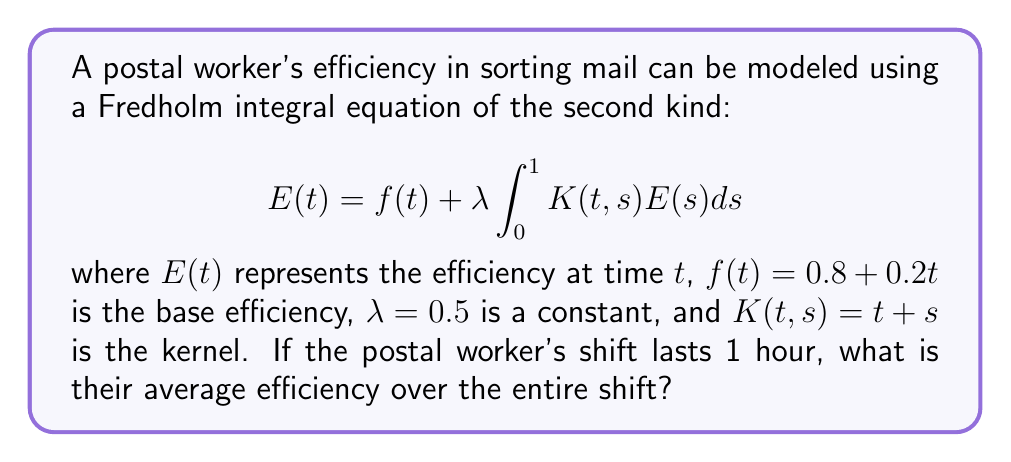Can you answer this question? To solve this problem, we'll follow these steps:

1) First, we need to solve the Fredholm integral equation to find $E(t)$. We'll assume a solution of the form:
   $$E(t) = a + bt$$

2) Substituting this into the original equation:
   $$(a + bt) = (0.8 + 0.2t) + 0.5 \int_0^1 (t+s)(a + bs)ds$$

3) Evaluate the integral:
   $$\int_0^1 (t+s)(a + bs)ds = \int_0^1 (at + as + bst + bs^2)ds$$
   $$= at + as|_0^1 + bst|_0^1 + \frac{1}{3}bs^3|_0^1$$
   $$= at + a + \frac{1}{2}bt + \frac{1}{3}b$$

4) Substituting back:
   $$(a + bt) = (0.8 + 0.2t) + 0.5(at + a + \frac{1}{2}bt + \frac{1}{3}b)$$

5) Equating coefficients of $t$ and constant terms:
   For $t$: $b = 0.2 + 0.5a + 0.25b$
   Constant: $a = 0.8 + 0.5a + \frac{1}{6}b$

6) Solve this system of equations:
   $0.75b = 0.2 + 0.5a$
   $0.5a = 0.8 - \frac{1}{6}b$

   Solving these, we get: $a \approx 1.0909$ and $b \approx 0.7273$

7) Therefore, $E(t) = 1.0909 + 0.7273t$

8) To find the average efficiency, we integrate $E(t)$ over the shift and divide by the shift length:

   $$\text{Average Efficiency} = \frac{1}{1} \int_0^1 (1.0909 + 0.7273t)dt$$
   $$= 1.0909 + 0.7273 \cdot \frac{1}{2} = 1.4545$$
Answer: 1.4545 